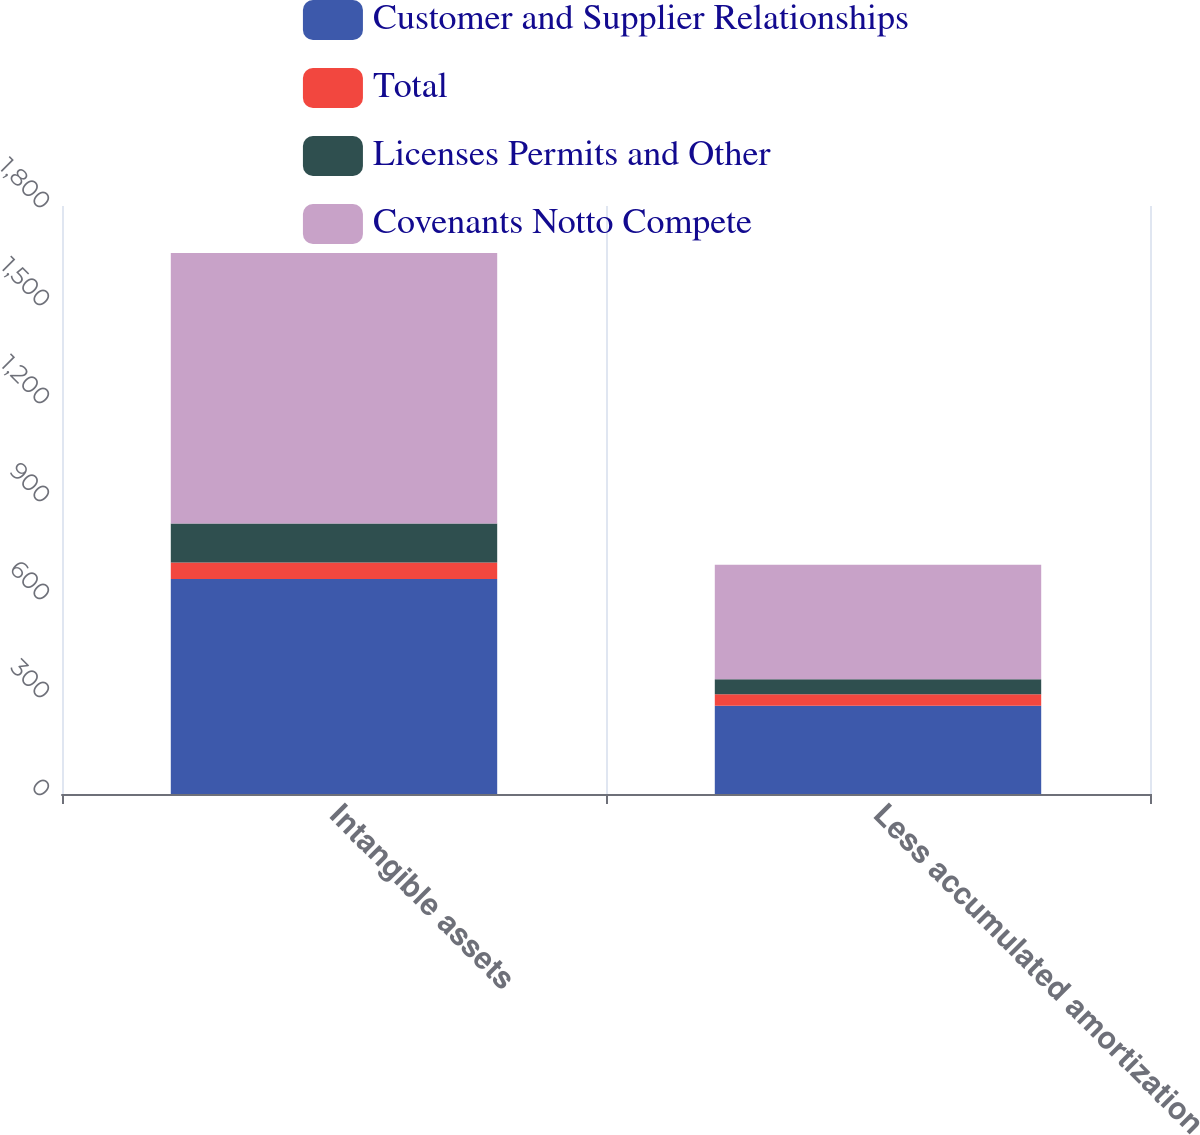<chart> <loc_0><loc_0><loc_500><loc_500><stacked_bar_chart><ecel><fcel>Intangible assets<fcel>Less accumulated amortization<nl><fcel>Customer and Supplier Relationships<fcel>658<fcel>270<nl><fcel>Total<fcel>51<fcel>35<nl><fcel>Licenses Permits and Other<fcel>119<fcel>46<nl><fcel>Covenants Notto Compete<fcel>828<fcel>351<nl></chart> 